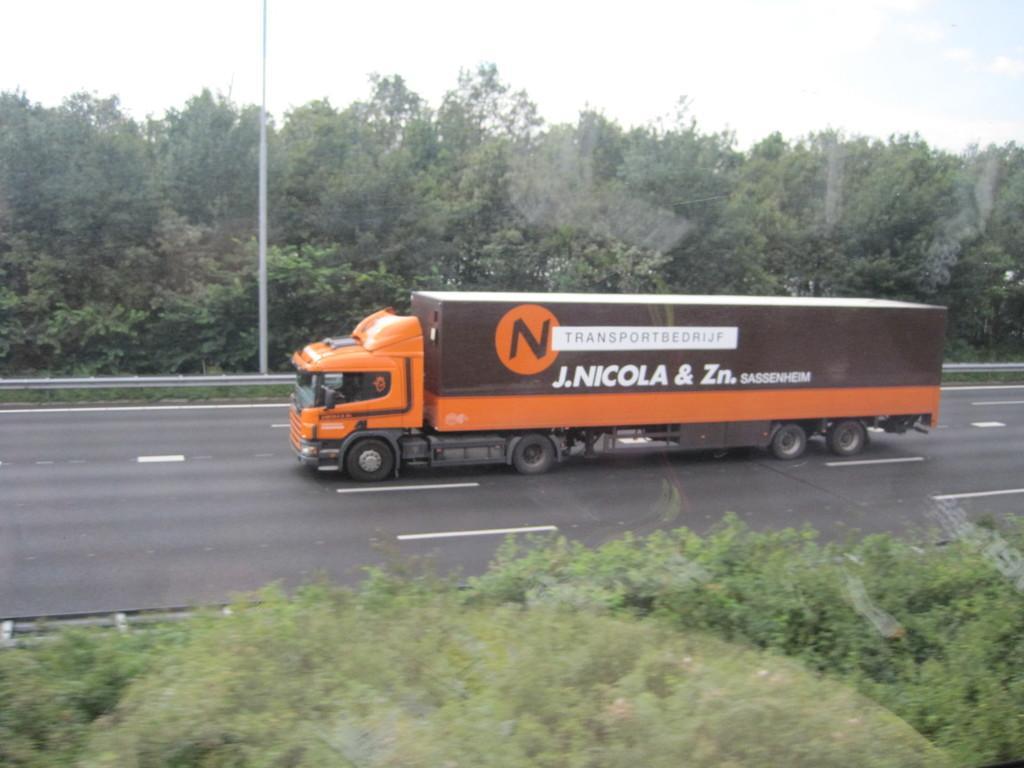Please provide a concise description of this image. In this picture we can see a vehicle on the road, trees, leaves and pole. In the background of the image we can see the sky. 